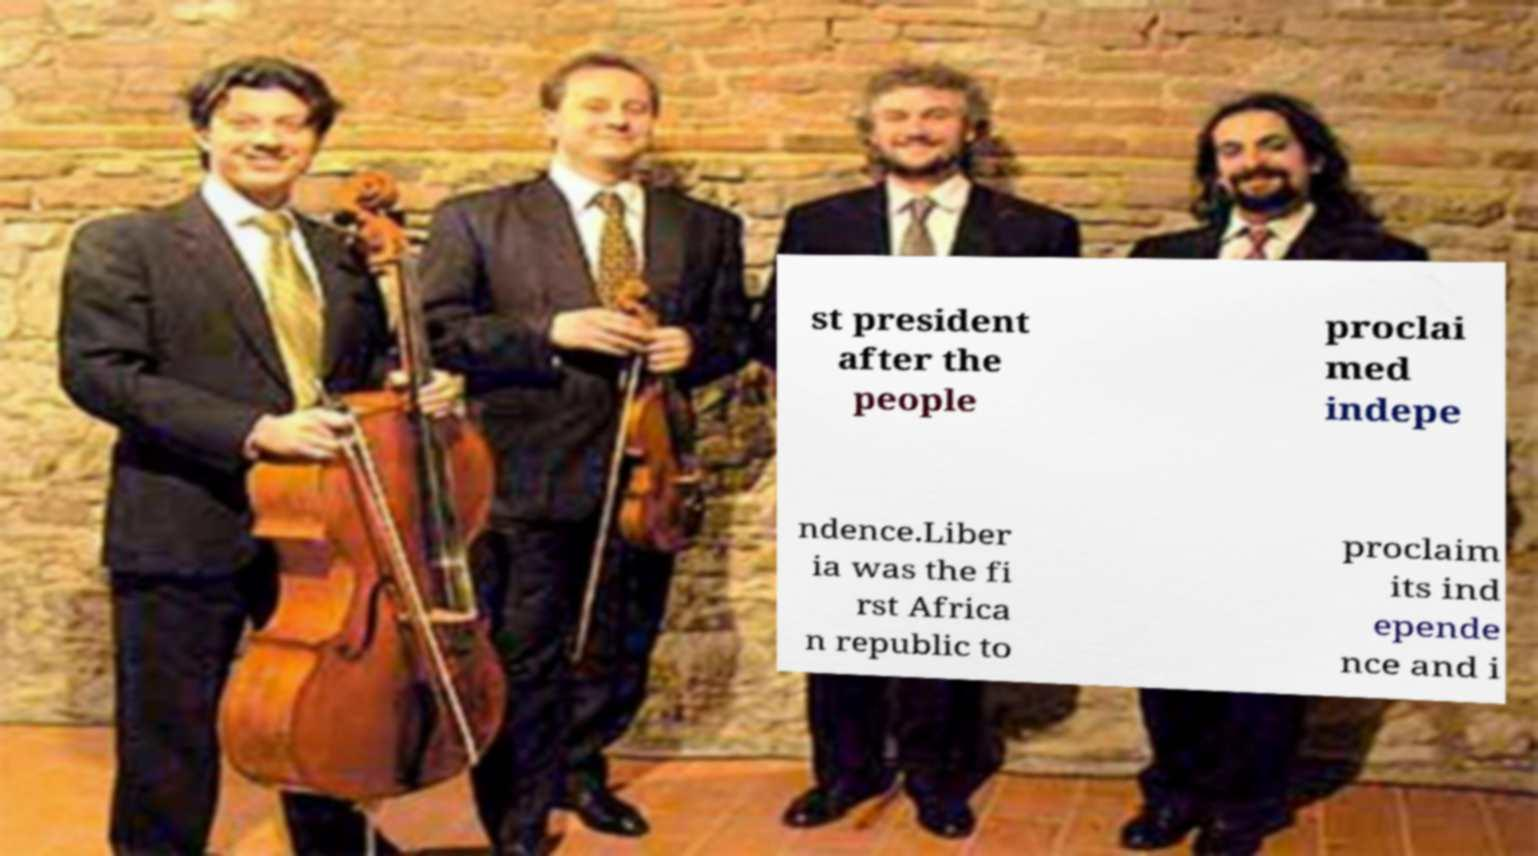There's text embedded in this image that I need extracted. Can you transcribe it verbatim? st president after the people proclai med indepe ndence.Liber ia was the fi rst Africa n republic to proclaim its ind epende nce and i 